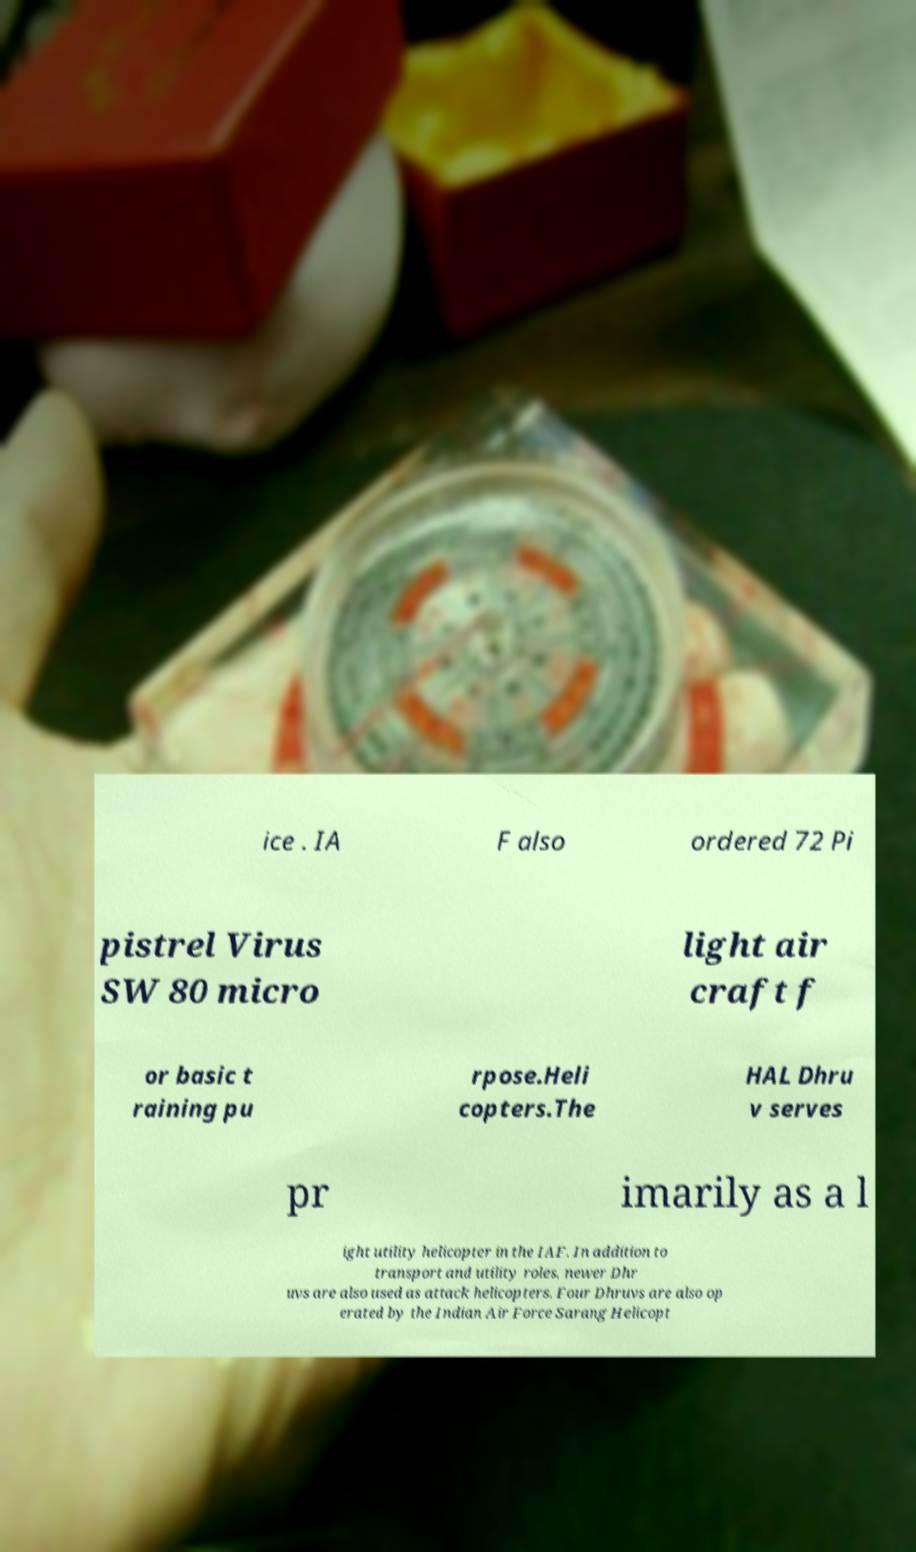What messages or text are displayed in this image? I need them in a readable, typed format. ice . IA F also ordered 72 Pi pistrel Virus SW 80 micro light air craft f or basic t raining pu rpose.Heli copters.The HAL Dhru v serves pr imarily as a l ight utility helicopter in the IAF. In addition to transport and utility roles, newer Dhr uvs are also used as attack helicopters. Four Dhruvs are also op erated by the Indian Air Force Sarang Helicopt 